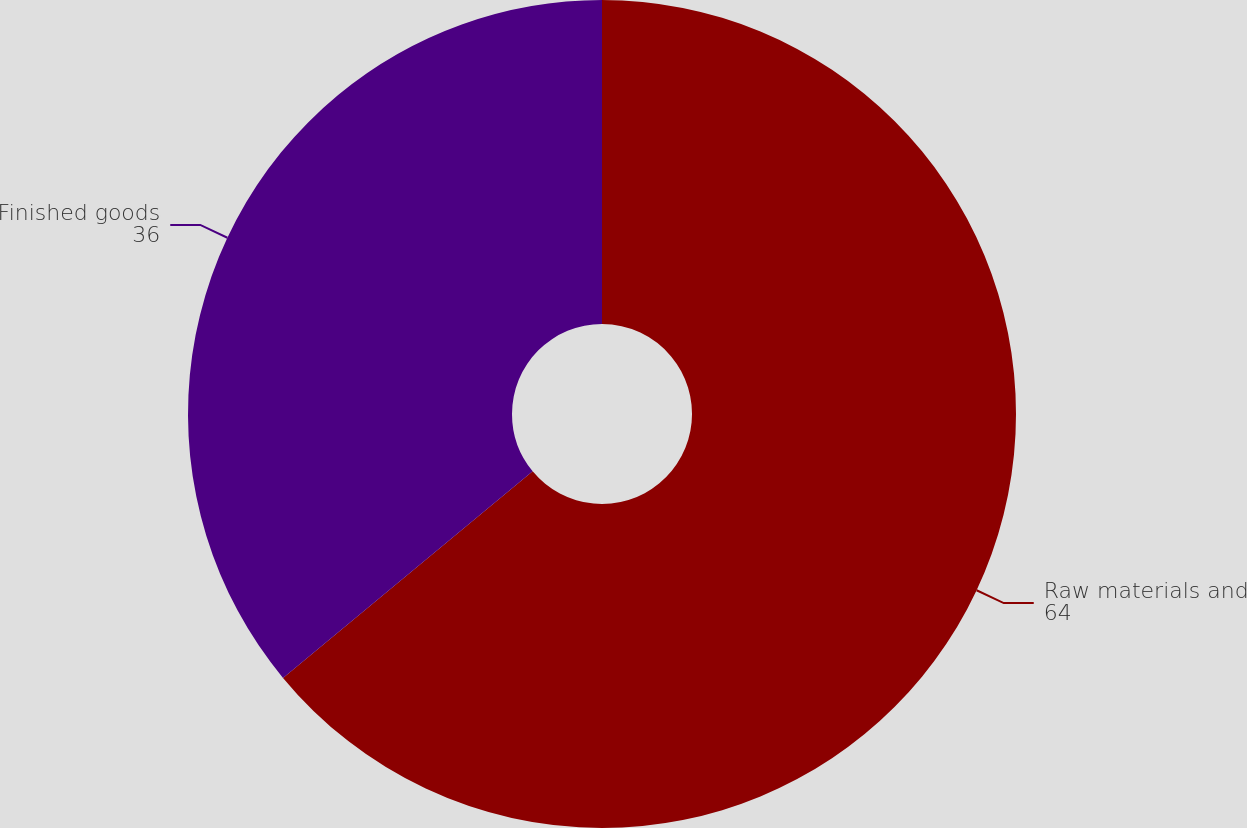Convert chart. <chart><loc_0><loc_0><loc_500><loc_500><pie_chart><fcel>Raw materials and<fcel>Finished goods<nl><fcel>64.0%<fcel>36.0%<nl></chart> 